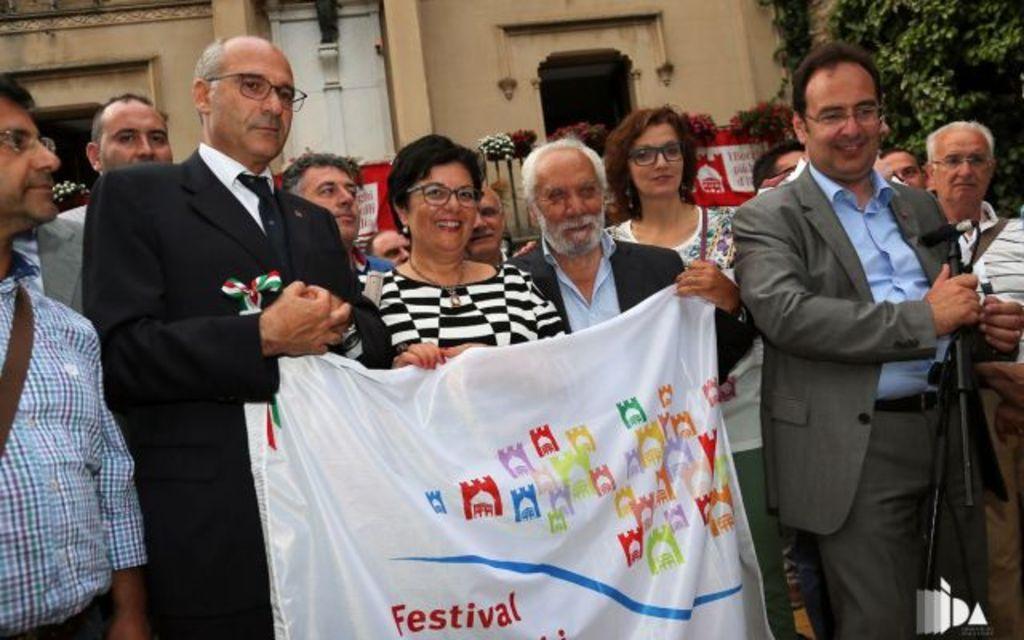Describe this image in one or two sentences. People are standing and holding a white banner. Behind them there are buildings and trees. 